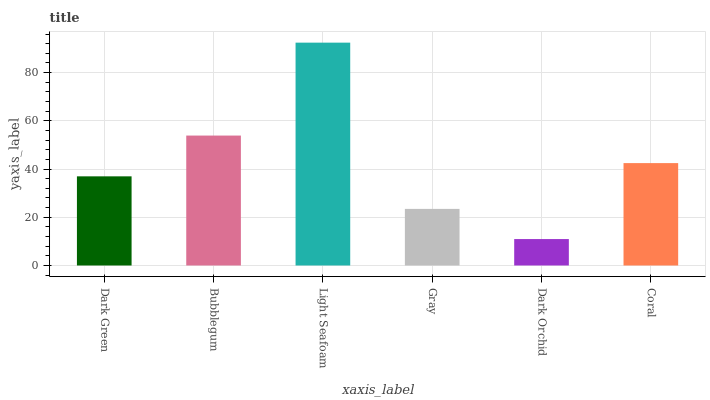Is Bubblegum the minimum?
Answer yes or no. No. Is Bubblegum the maximum?
Answer yes or no. No. Is Bubblegum greater than Dark Green?
Answer yes or no. Yes. Is Dark Green less than Bubblegum?
Answer yes or no. Yes. Is Dark Green greater than Bubblegum?
Answer yes or no. No. Is Bubblegum less than Dark Green?
Answer yes or no. No. Is Coral the high median?
Answer yes or no. Yes. Is Dark Green the low median?
Answer yes or no. Yes. Is Gray the high median?
Answer yes or no. No. Is Light Seafoam the low median?
Answer yes or no. No. 